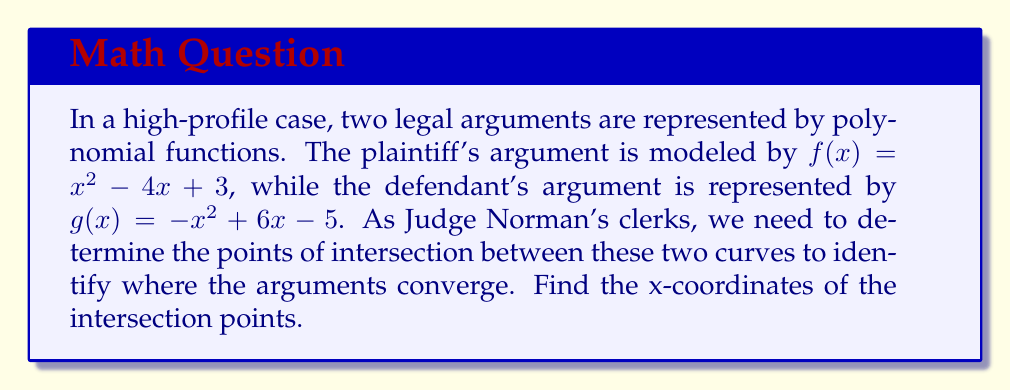Can you solve this math problem? 1) To find the intersection points, we need to solve the equation $f(x) = g(x)$:

   $x^2 - 4x + 3 = -x^2 + 6x - 5$

2) Rearrange the equation to standard form:

   $x^2 - 4x + 3 + x^2 - 6x + 5 = 0$
   $2x^2 - 10x + 8 = 0$

3) Divide all terms by 2 to simplify:

   $x^2 - 5x + 4 = 0$

4) This is a quadratic equation. We can solve it using the quadratic formula:
   $x = \frac{-b \pm \sqrt{b^2 - 4ac}}{2a}$

   Where $a = 1$, $b = -5$, and $c = 4$

5) Substituting these values:

   $x = \frac{5 \pm \sqrt{25 - 16}}{2} = \frac{5 \pm \sqrt{9}}{2} = \frac{5 \pm 3}{2}$

6) This gives us two solutions:

   $x_1 = \frac{5 + 3}{2} = 4$ and $x_2 = \frac{5 - 3}{2} = 1$

Therefore, the x-coordinates of the intersection points are 1 and 4.
Answer: $x = 1$ and $x = 4$ 